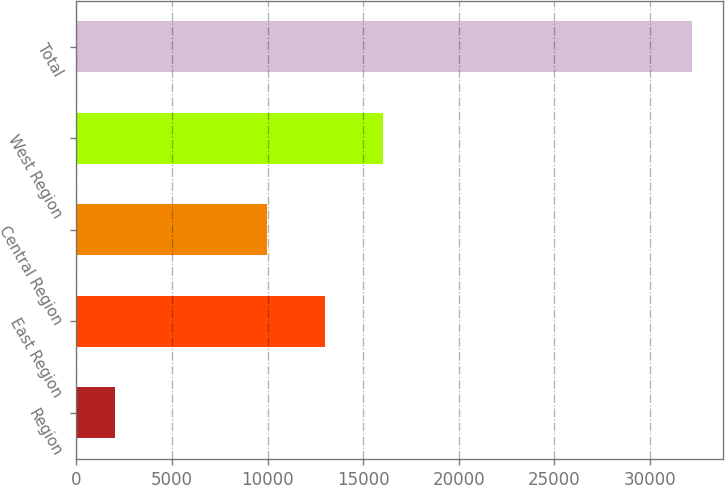Convert chart to OTSL. <chart><loc_0><loc_0><loc_500><loc_500><bar_chart><fcel>Region<fcel>East Region<fcel>Central Region<fcel>West Region<fcel>Total<nl><fcel>2003<fcel>13010.7<fcel>9993<fcel>16028.4<fcel>32180<nl></chart> 